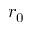Convert formula to latex. <formula><loc_0><loc_0><loc_500><loc_500>r _ { 0 }</formula> 